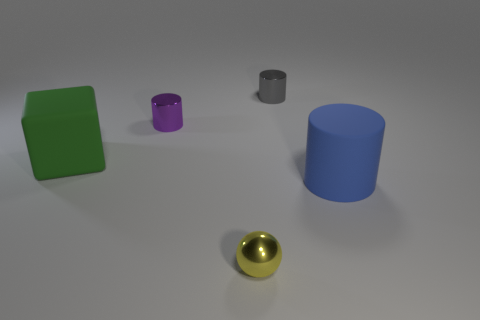Add 1 big rubber cylinders. How many objects exist? 6 Subtract all tiny gray metal cylinders. How many cylinders are left? 2 Subtract all purple cylinders. How many cylinders are left? 2 Subtract 1 spheres. How many spheres are left? 0 Add 3 purple things. How many purple things are left? 4 Add 4 metal objects. How many metal objects exist? 7 Subtract 0 yellow cylinders. How many objects are left? 5 Subtract all spheres. How many objects are left? 4 Subtract all blue balls. Subtract all red cylinders. How many balls are left? 1 Subtract all red cubes. How many blue balls are left? 0 